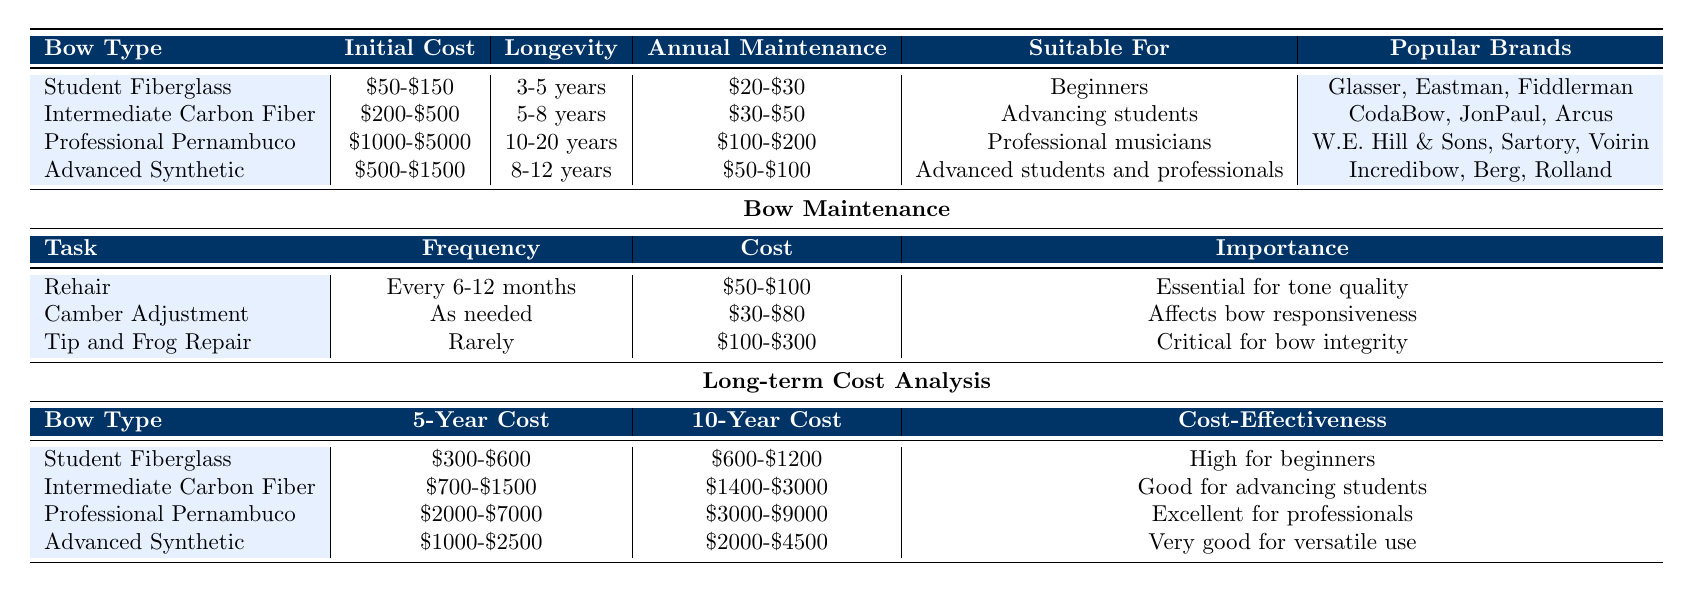What is the initial cost range for a Student Fiberglass Bow? The table lists the initial cost for a Student Fiberglass Bow as "$50-$150".
Answer: $50-$150 How long is the longevity of a Professional Pernambuco Bow? The table indicates that the longevity range for a Professional Pernambuco Bow is "10-20 years".
Answer: 10-20 years What is the annual maintenance cost for an Intermediate Carbon Fiber Bow? According to the table, the annual maintenance cost for an Intermediate Carbon Fiber Bow is "$30-$50".
Answer: $30-$50 Which type of bow is suitable for beginners? The table shows that the Student Fiberglass Bow is suitable for "Beginners".
Answer: Student Fiberglass Bow How many popular brands are listed for the Advanced Synthetic Bow? There are three brands listed for the Advanced Synthetic Bow: "Incredibow, Berg, Rolland", which counts as 3.
Answer: 3 What is the average 5-year cost of a Student Fiberglass Bow? The range given for the 5-year cost of a Student Fiberglass Bow is "$300-$600". To find an average, we take (300 + 600) / 2 = 450.
Answer: $450 Is a Professional Pernambuco Bow considered cost-effective for professionals? The table states that it is "Excellent for professionals", indicating that it is indeed considered cost-effective.
Answer: Yes If a student uses an Intermediate Carbon Fiber Bow for ten years, what will be their approximate total cost? The 10-year cost for an Intermediate Carbon Fiber Bow is "$1400-$3000". This range indicates that the approximate total cost will be anywhere between $1400 and $3000, depending on specific factors.
Answer: $1400-$3000 What is the total maintenance cost over five years for a Professional Pernambuco Bow? The annual maintenance cost for a Professional Pernambuco Bow is "$100-$200". Over five years, this totals to between $500 and $1000, calculated as (5 x 100) to (5 x 200).
Answer: $500-$1000 Do all bows require rehairing at a set frequency? The table states that rehairing needs to occur "Every 6-12 months", which means it does have a set frequency.
Answer: Yes Which bow type has the shortest longevity? The table indicates that the Student Fiberglass Bow has the shortest longevity range of "3-5 years".
Answer: Student Fiberglass Bow 